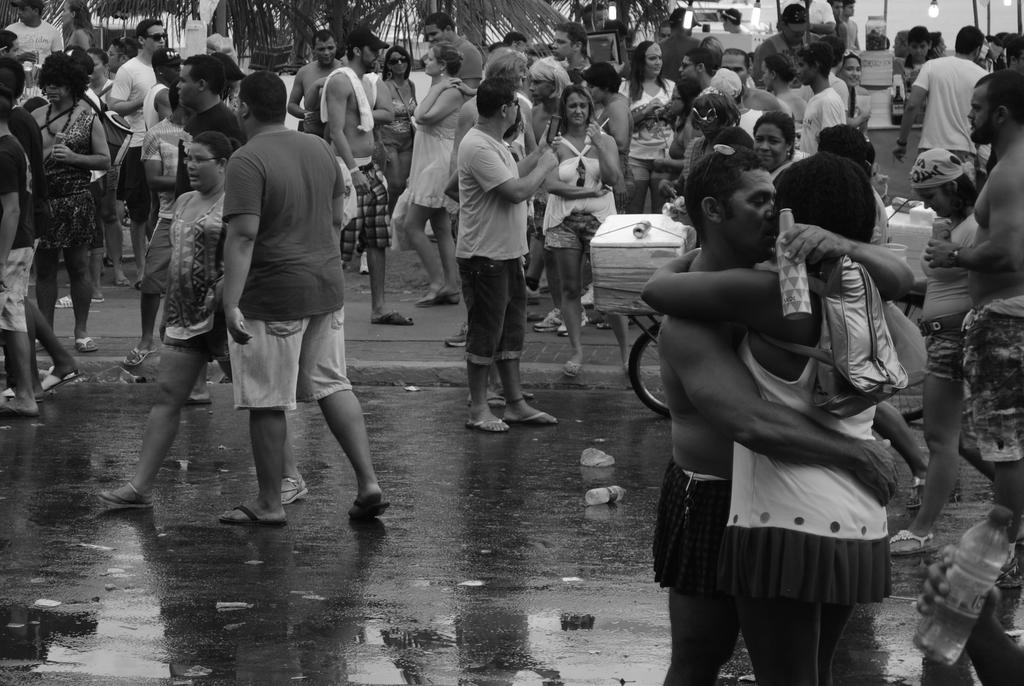How many people are in the image? There is a group of people in the image. Where are the people located in the image? The people are on the road. What can be seen in the background of the image? There are trees in the background of the image. What type of apparel is the group of people wearing in the image? The provided facts do not mention any specific apparel worn by the group of people in the image. 